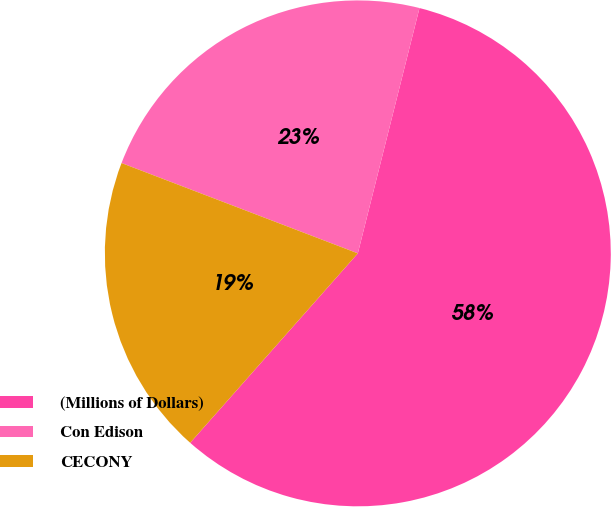Convert chart to OTSL. <chart><loc_0><loc_0><loc_500><loc_500><pie_chart><fcel>(Millions of Dollars)<fcel>Con Edison<fcel>CECONY<nl><fcel>57.61%<fcel>23.11%<fcel>19.28%<nl></chart> 